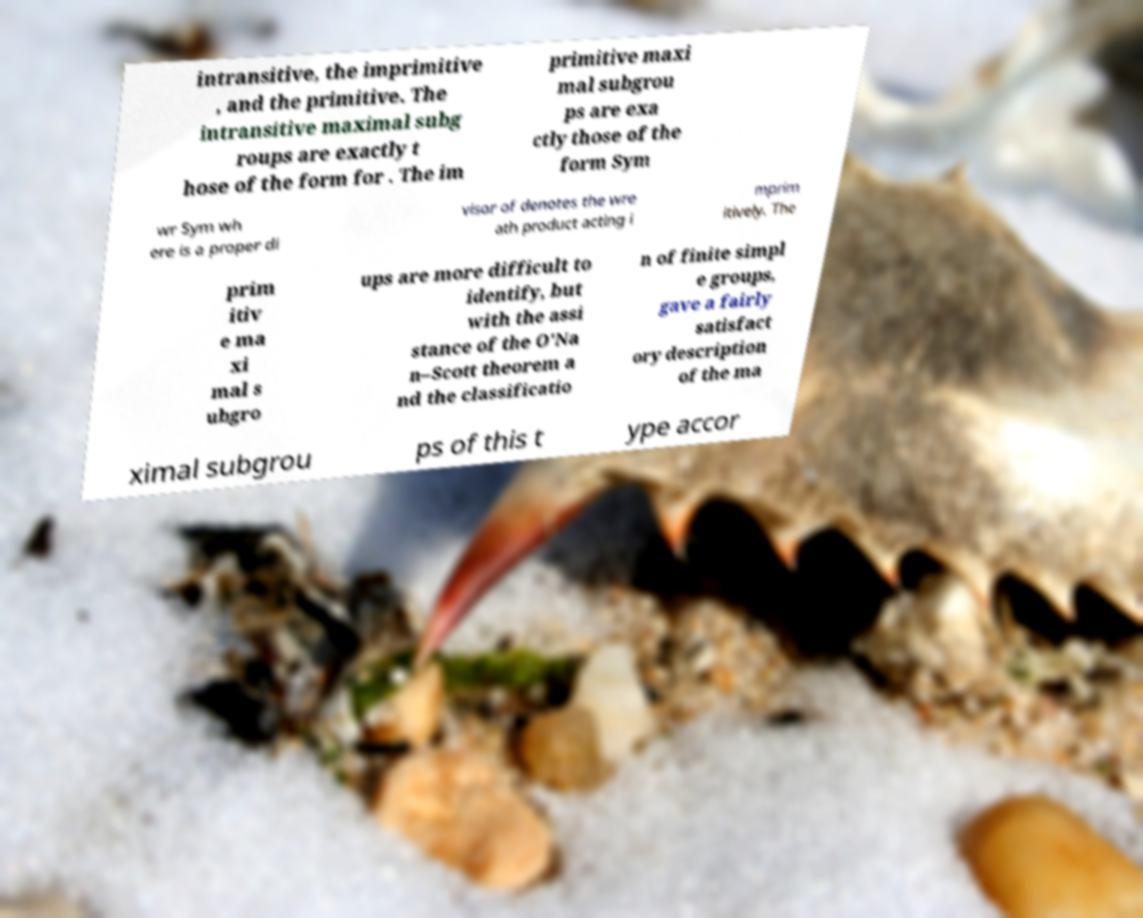What messages or text are displayed in this image? I need them in a readable, typed format. intransitive, the imprimitive , and the primitive. The intransitive maximal subg roups are exactly t hose of the form for . The im primitive maxi mal subgrou ps are exa ctly those of the form Sym wr Sym wh ere is a proper di visor of denotes the wre ath product acting i mprim itively. The prim itiv e ma xi mal s ubgro ups are more difficult to identify, but with the assi stance of the O'Na n–Scott theorem a nd the classificatio n of finite simpl e groups, gave a fairly satisfact ory description of the ma ximal subgrou ps of this t ype accor 